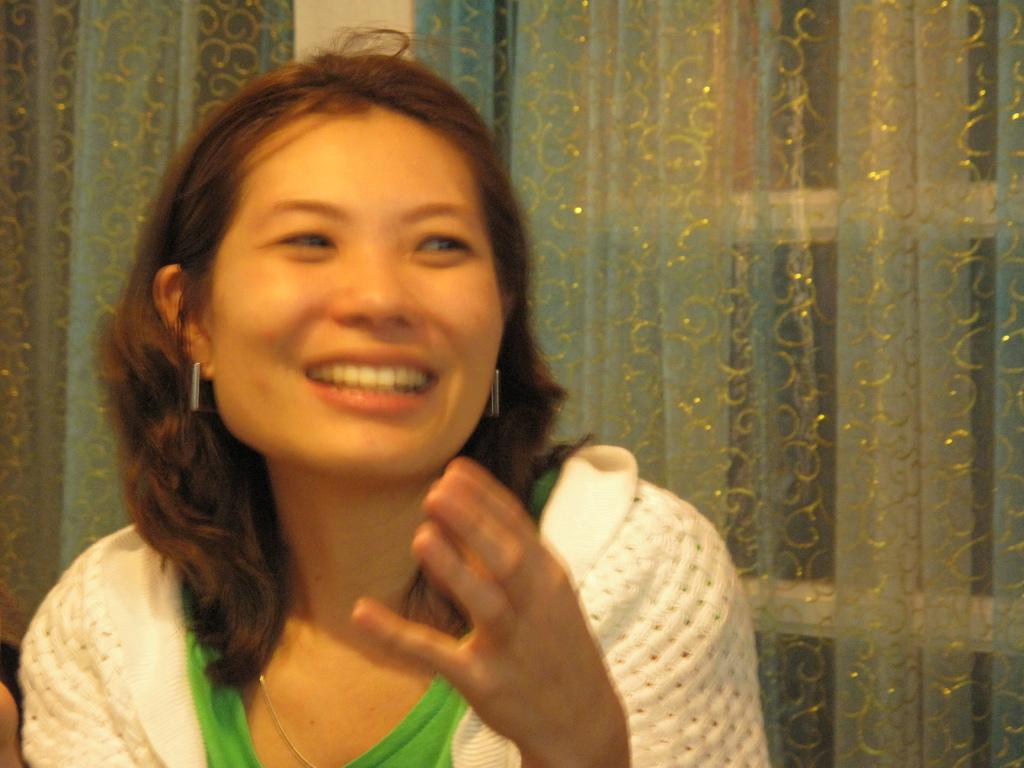Who is present in the image? There is a woman in the image. What can be seen in the background of the image? There is a window visible in the image. Is there any window treatment present in the image? Yes, there is a curtain associated with the window. What action is the beetle performing in the image? There is no beetle present in the image, so it cannot be performing any action. 